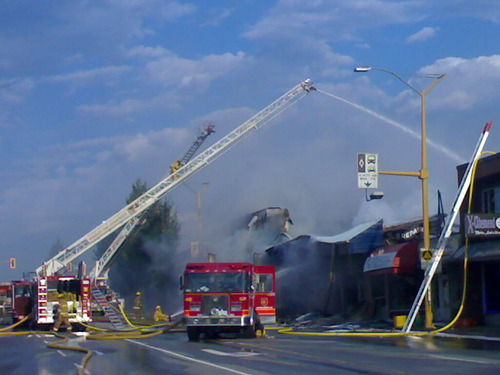<image>
Is there a building above the truck? No. The building is not positioned above the truck. The vertical arrangement shows a different relationship. 